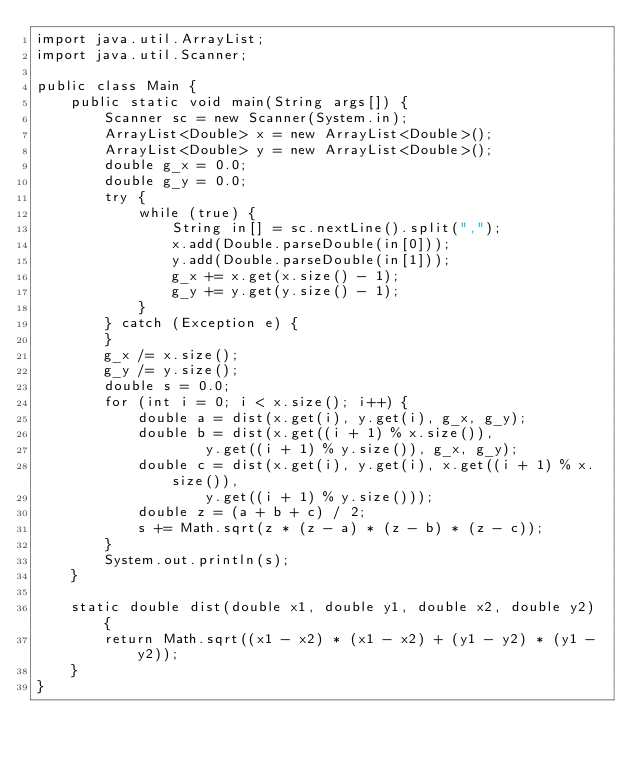<code> <loc_0><loc_0><loc_500><loc_500><_Java_>import java.util.ArrayList;
import java.util.Scanner;

public class Main {
	public static void main(String args[]) {
		Scanner sc = new Scanner(System.in);
		ArrayList<Double> x = new ArrayList<Double>();
		ArrayList<Double> y = new ArrayList<Double>();
		double g_x = 0.0;
		double g_y = 0.0;
		try {
			while (true) {
				String in[] = sc.nextLine().split(",");
				x.add(Double.parseDouble(in[0]));
				y.add(Double.parseDouble(in[1]));
				g_x += x.get(x.size() - 1);
				g_y += y.get(y.size() - 1);
			}
		} catch (Exception e) {
		}
		g_x /= x.size();
		g_y /= y.size();
		double s = 0.0;
		for (int i = 0; i < x.size(); i++) {
			double a = dist(x.get(i), y.get(i), g_x, g_y);
			double b = dist(x.get((i + 1) % x.size()),
					y.get((i + 1) % y.size()), g_x, g_y);
			double c = dist(x.get(i), y.get(i), x.get((i + 1) % x.size()),
					y.get((i + 1) % y.size()));
			double z = (a + b + c) / 2;
			s += Math.sqrt(z * (z - a) * (z - b) * (z - c));
		}
		System.out.println(s);
	}

	static double dist(double x1, double y1, double x2, double y2) {
		return Math.sqrt((x1 - x2) * (x1 - x2) + (y1 - y2) * (y1 - y2));
	}
}</code> 